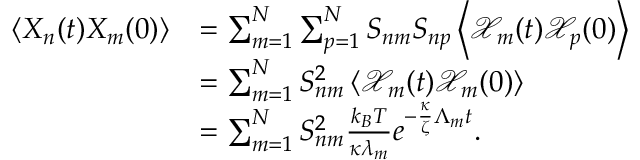Convert formula to latex. <formula><loc_0><loc_0><loc_500><loc_500>\begin{array} { r l } { \left < X _ { n } ( t ) X _ { m } ( 0 ) \right > } & { = \sum _ { m = 1 } ^ { N } \sum _ { p = 1 } ^ { N } S _ { n m } S _ { n p } \left < \mathcal { X } _ { m } ( t ) \mathcal { X } _ { p } ( 0 ) \right > } \\ & { = \sum _ { m = 1 } ^ { N } S _ { n m } ^ { 2 } \left < \mathcal { X } _ { m } ( t ) \mathcal { X } _ { m } ( 0 ) \right > } \\ & { = \sum _ { m = 1 } ^ { N } S _ { n m } ^ { 2 } \frac { k _ { B } T } { \kappa \lambda _ { m } } e ^ { - \frac { \kappa } { \zeta } \Lambda _ { m } t } . } \end{array}</formula> 